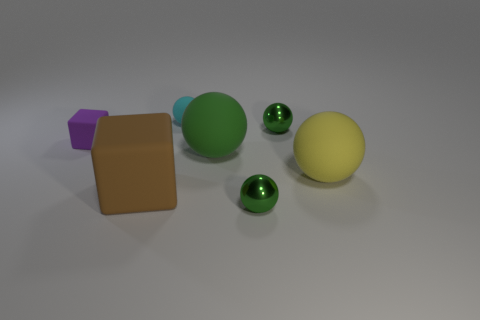The large cube is what color?
Provide a succinct answer. Brown. What number of big brown rubber things are the same shape as the large green object?
Give a very brief answer. 0. Are the green object that is in front of the yellow thing and the small object that is to the left of the cyan matte sphere made of the same material?
Keep it short and to the point. No. There is a green shiny ball that is behind the small green metallic object in front of the green rubber object; what size is it?
Keep it short and to the point. Small. Are there any other things that are the same size as the yellow rubber sphere?
Your answer should be very brief. Yes. There is a small purple thing that is the same shape as the large brown rubber object; what is its material?
Ensure brevity in your answer.  Rubber. There is a green object in front of the green matte object; does it have the same shape as the big object behind the large yellow object?
Give a very brief answer. Yes. Is the number of small green rubber cubes greater than the number of small green things?
Your answer should be very brief. No. The brown block is what size?
Provide a short and direct response. Large. What number of other objects are the same color as the small rubber cube?
Ensure brevity in your answer.  0. 